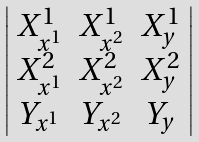Convert formula to latex. <formula><loc_0><loc_0><loc_500><loc_500>\left | \begin{array} { c c c } X _ { x ^ { 1 } } ^ { 1 } & X _ { x ^ { 2 } } ^ { 1 } & X _ { y } ^ { 1 } \\ X _ { x ^ { 1 } } ^ { 2 } & X _ { x ^ { 2 } } ^ { 2 } & X _ { y } ^ { 2 } \\ Y _ { x ^ { 1 } } & Y _ { x ^ { 2 } } & Y _ { y } \\ \end{array} \right |</formula> 